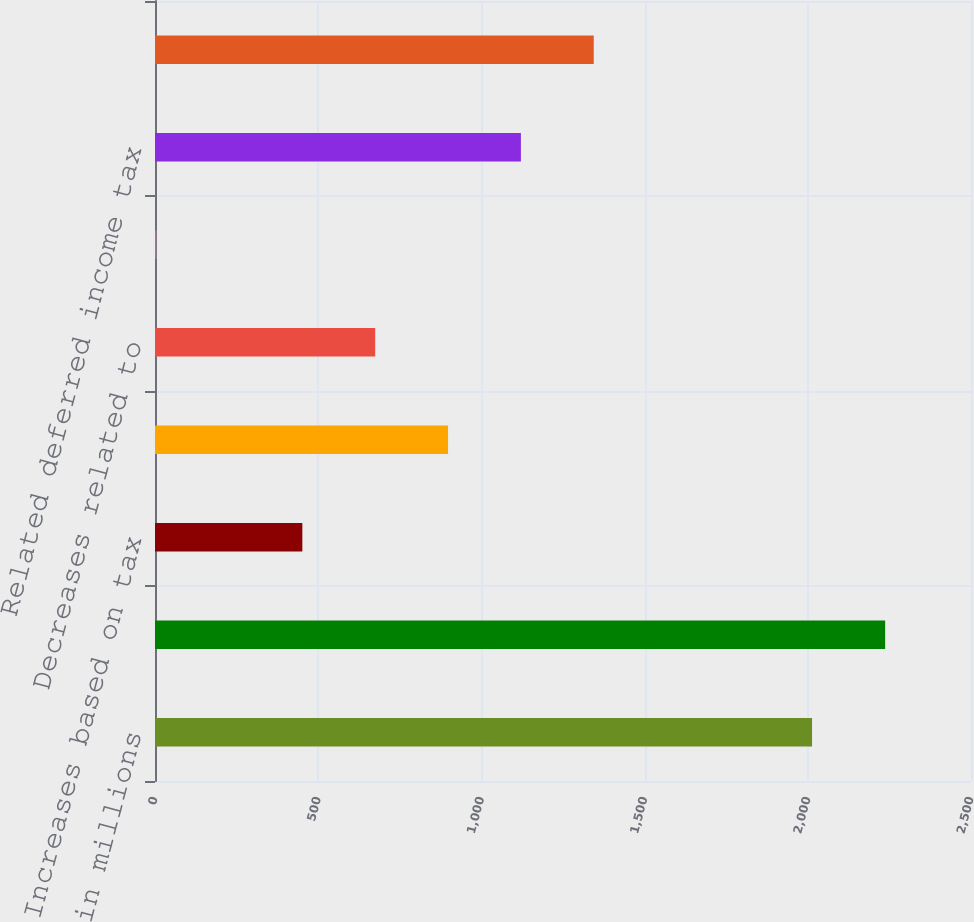Convert chart. <chart><loc_0><loc_0><loc_500><loc_500><bar_chart><fcel>in millions<fcel>Balance beginning of year<fcel>Increases based on tax<fcel>Decreases based on tax<fcel>Decreases related to<fcel>Exchange rate fluctuations<fcel>Related deferred income tax<fcel>Net unrecognized tax benefit 2<nl><fcel>2013<fcel>2237<fcel>451.4<fcel>897.8<fcel>674.6<fcel>5<fcel>1121<fcel>1344.2<nl></chart> 